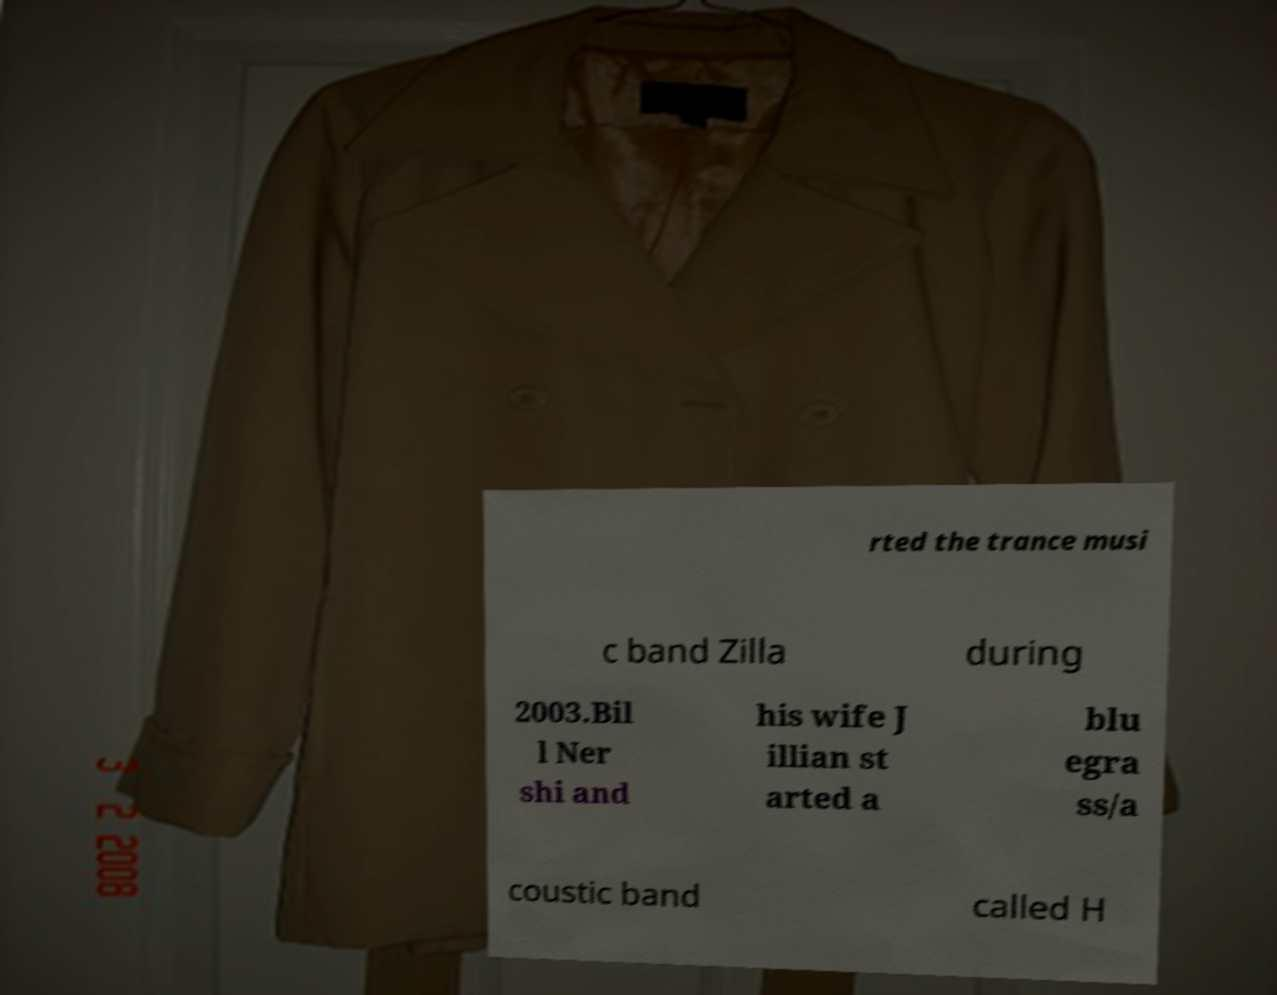I need the written content from this picture converted into text. Can you do that? rted the trance musi c band Zilla during 2003.Bil l Ner shi and his wife J illian st arted a blu egra ss/a coustic band called H 